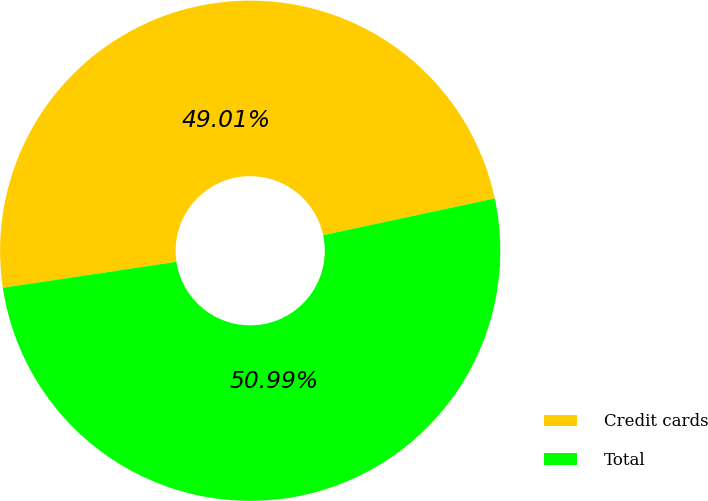Convert chart to OTSL. <chart><loc_0><loc_0><loc_500><loc_500><pie_chart><fcel>Credit cards<fcel>Total<nl><fcel>49.01%<fcel>50.99%<nl></chart> 